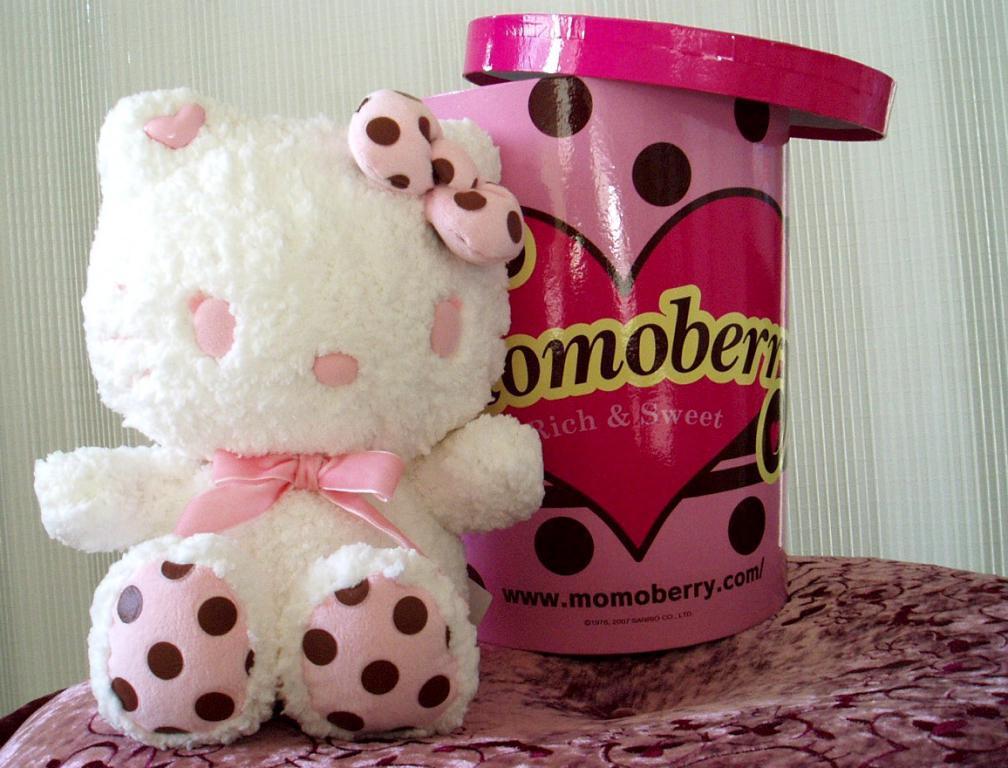How would you summarize this image in a sentence or two? In the picture we can see a teddy doll which is white in color which is placed on the soft surface and besides it, we can see a tin with a painting on it as heart shaped and named Momo berry, in the background we can see a wall which is white in color with lines. 